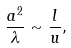Convert formula to latex. <formula><loc_0><loc_0><loc_500><loc_500>\frac { a ^ { 2 } } { \lambda } \sim \frac { l } { u } ,</formula> 